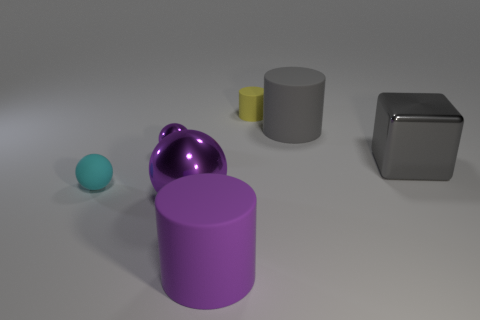What is the material of the tiny cyan ball?
Offer a very short reply. Rubber. There is a small rubber sphere; are there any purple metallic things behind it?
Your response must be concise. Yes. Do the cyan thing and the purple rubber thing have the same shape?
Offer a terse response. No. How many other objects are there of the same size as the cyan matte object?
Offer a terse response. 2. What number of objects are gray things that are behind the tiny purple metallic object or red spheres?
Keep it short and to the point. 1. What color is the large sphere?
Your answer should be compact. Purple. What is the large object behind the small purple shiny thing made of?
Make the answer very short. Rubber. There is a small purple object; does it have the same shape as the tiny rubber thing that is behind the gray metallic block?
Make the answer very short. No. Are there more small rubber balls than small gray matte cylinders?
Give a very brief answer. Yes. Is there anything else of the same color as the small rubber cylinder?
Your answer should be compact. No. 